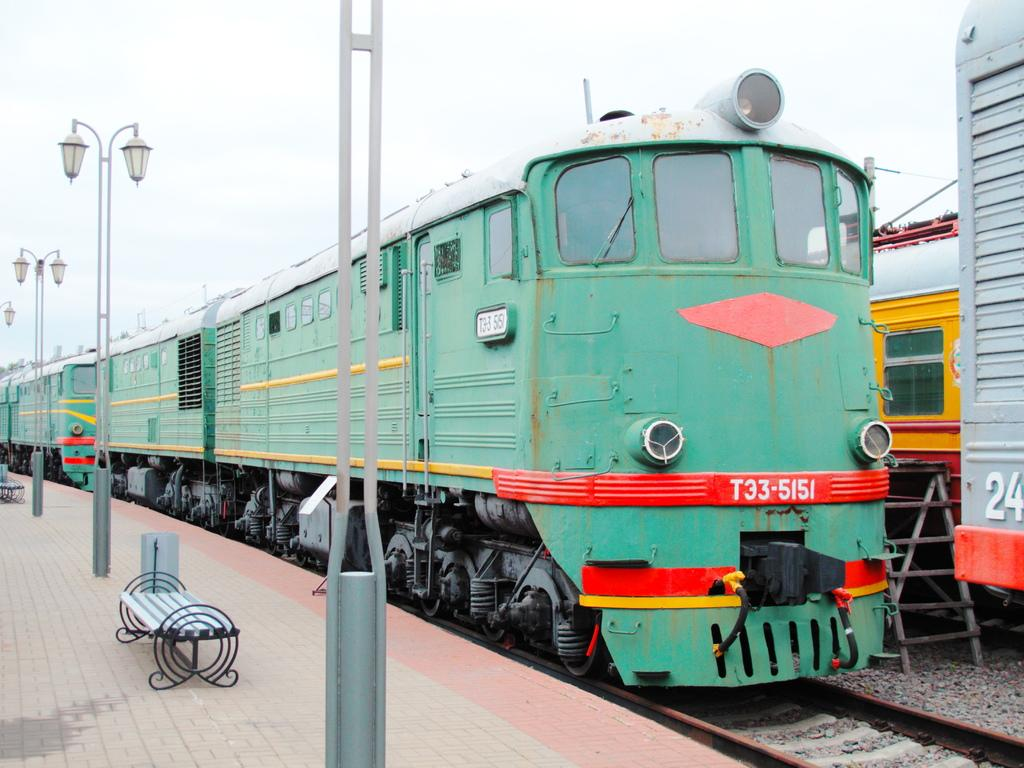Provide a one-sentence caption for the provided image. A large green train with the labeling T33-5151 sits on a track. 